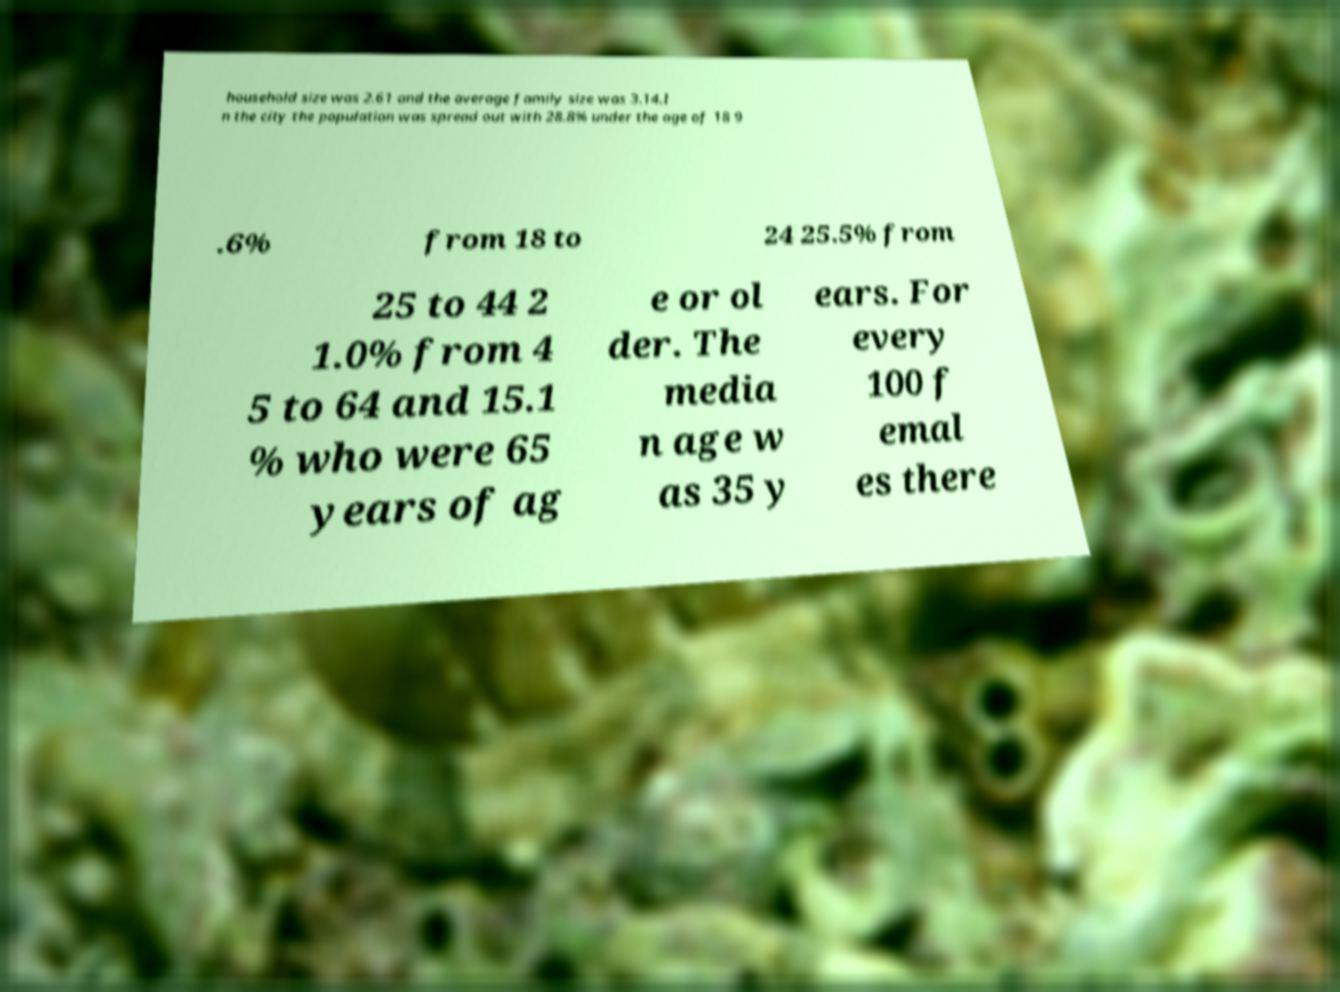Can you accurately transcribe the text from the provided image for me? household size was 2.61 and the average family size was 3.14.I n the city the population was spread out with 28.8% under the age of 18 9 .6% from 18 to 24 25.5% from 25 to 44 2 1.0% from 4 5 to 64 and 15.1 % who were 65 years of ag e or ol der. The media n age w as 35 y ears. For every 100 f emal es there 